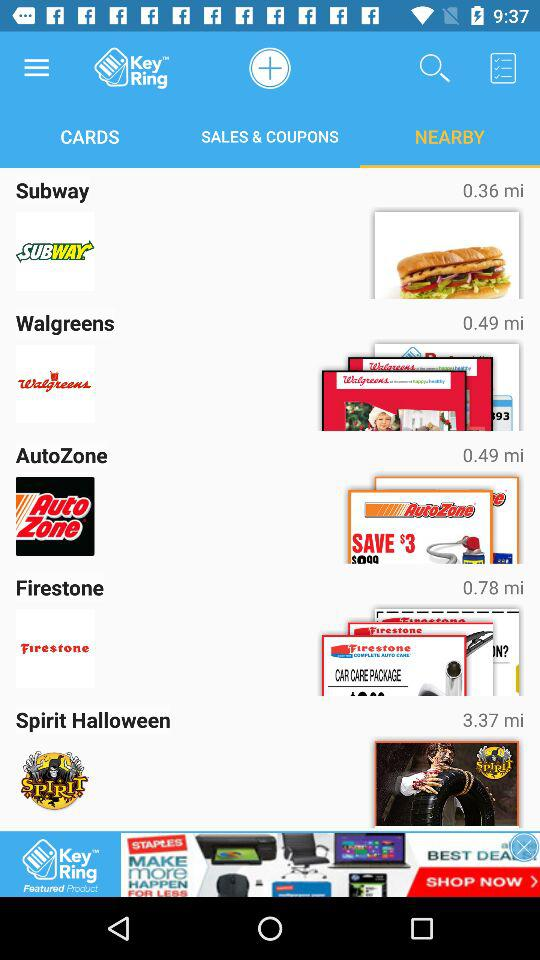What is the application name? The application name is "Key Ring". 